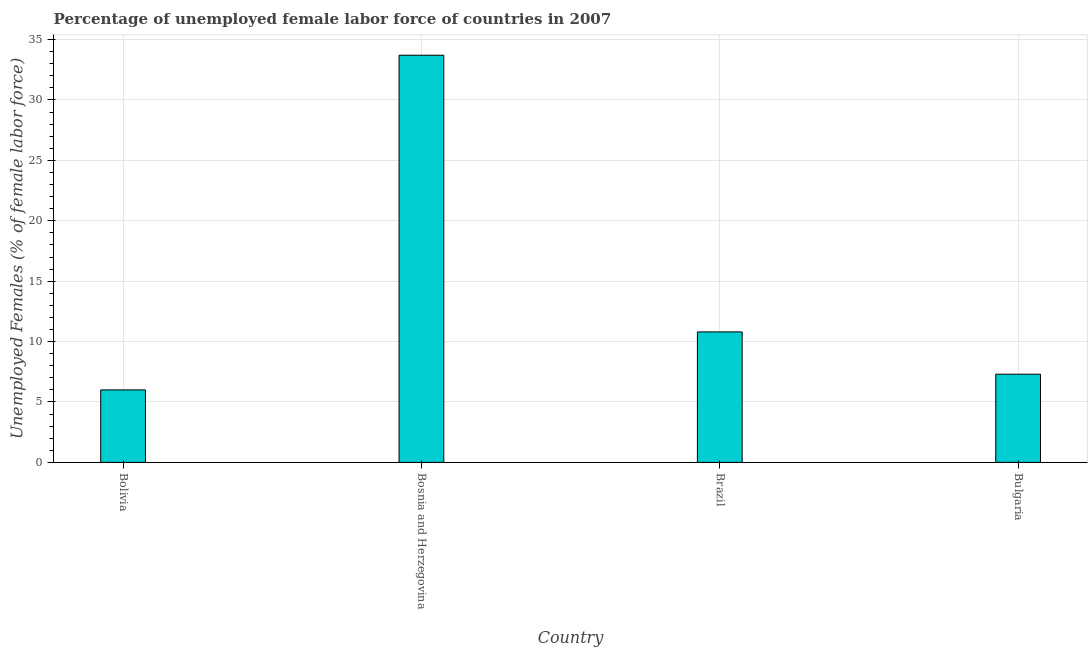Does the graph contain grids?
Give a very brief answer. Yes. What is the title of the graph?
Your answer should be very brief. Percentage of unemployed female labor force of countries in 2007. What is the label or title of the Y-axis?
Offer a very short reply. Unemployed Females (% of female labor force). What is the total unemployed female labour force in Bolivia?
Ensure brevity in your answer.  6. Across all countries, what is the maximum total unemployed female labour force?
Keep it short and to the point. 33.7. Across all countries, what is the minimum total unemployed female labour force?
Offer a terse response. 6. In which country was the total unemployed female labour force maximum?
Ensure brevity in your answer.  Bosnia and Herzegovina. What is the sum of the total unemployed female labour force?
Provide a short and direct response. 57.8. What is the average total unemployed female labour force per country?
Your answer should be compact. 14.45. What is the median total unemployed female labour force?
Your answer should be compact. 9.05. What is the ratio of the total unemployed female labour force in Bolivia to that in Brazil?
Provide a succinct answer. 0.56. Is the total unemployed female labour force in Brazil less than that in Bulgaria?
Ensure brevity in your answer.  No. Is the difference between the total unemployed female labour force in Brazil and Bulgaria greater than the difference between any two countries?
Your response must be concise. No. What is the difference between the highest and the second highest total unemployed female labour force?
Provide a short and direct response. 22.9. Is the sum of the total unemployed female labour force in Bosnia and Herzegovina and Bulgaria greater than the maximum total unemployed female labour force across all countries?
Your response must be concise. Yes. What is the difference between the highest and the lowest total unemployed female labour force?
Make the answer very short. 27.7. Are all the bars in the graph horizontal?
Your answer should be very brief. No. How many countries are there in the graph?
Ensure brevity in your answer.  4. What is the difference between two consecutive major ticks on the Y-axis?
Keep it short and to the point. 5. Are the values on the major ticks of Y-axis written in scientific E-notation?
Ensure brevity in your answer.  No. What is the Unemployed Females (% of female labor force) in Bolivia?
Make the answer very short. 6. What is the Unemployed Females (% of female labor force) in Bosnia and Herzegovina?
Your answer should be compact. 33.7. What is the Unemployed Females (% of female labor force) of Brazil?
Keep it short and to the point. 10.8. What is the Unemployed Females (% of female labor force) of Bulgaria?
Provide a succinct answer. 7.3. What is the difference between the Unemployed Females (% of female labor force) in Bolivia and Bosnia and Herzegovina?
Your answer should be very brief. -27.7. What is the difference between the Unemployed Females (% of female labor force) in Bolivia and Brazil?
Provide a succinct answer. -4.8. What is the difference between the Unemployed Females (% of female labor force) in Bosnia and Herzegovina and Brazil?
Keep it short and to the point. 22.9. What is the difference between the Unemployed Females (% of female labor force) in Bosnia and Herzegovina and Bulgaria?
Your response must be concise. 26.4. What is the ratio of the Unemployed Females (% of female labor force) in Bolivia to that in Bosnia and Herzegovina?
Offer a terse response. 0.18. What is the ratio of the Unemployed Females (% of female labor force) in Bolivia to that in Brazil?
Keep it short and to the point. 0.56. What is the ratio of the Unemployed Females (% of female labor force) in Bolivia to that in Bulgaria?
Keep it short and to the point. 0.82. What is the ratio of the Unemployed Females (% of female labor force) in Bosnia and Herzegovina to that in Brazil?
Give a very brief answer. 3.12. What is the ratio of the Unemployed Females (% of female labor force) in Bosnia and Herzegovina to that in Bulgaria?
Your answer should be very brief. 4.62. What is the ratio of the Unemployed Females (% of female labor force) in Brazil to that in Bulgaria?
Provide a short and direct response. 1.48. 